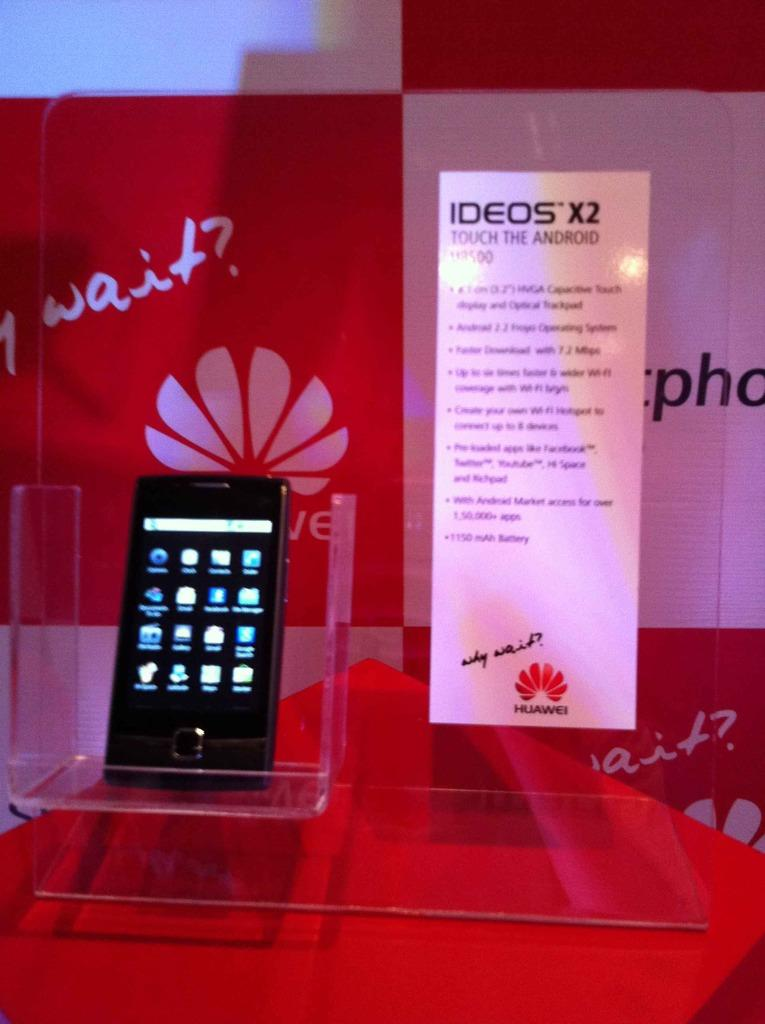Provide a one-sentence caption for the provided image. The new IDEOS X2 cell phone is on display at a Huawei table. 